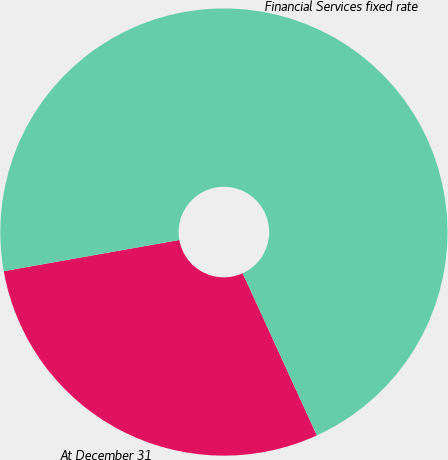Convert chart. <chart><loc_0><loc_0><loc_500><loc_500><pie_chart><fcel>At December 31<fcel>Financial Services fixed rate<nl><fcel>29.03%<fcel>70.97%<nl></chart> 